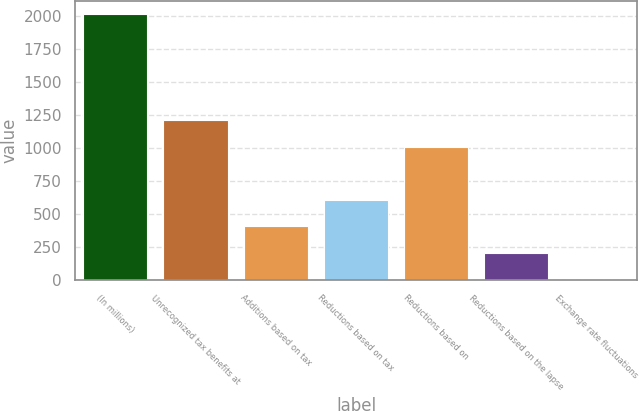<chart> <loc_0><loc_0><loc_500><loc_500><bar_chart><fcel>(In millions)<fcel>Unrecognized tax benefits at<fcel>Additions based on tax<fcel>Reductions based on tax<fcel>Reductions based on<fcel>Reductions based on the lapse<fcel>Exchange rate fluctuations<nl><fcel>2016<fcel>1211.2<fcel>406.4<fcel>607.6<fcel>1010<fcel>205.2<fcel>4<nl></chart> 